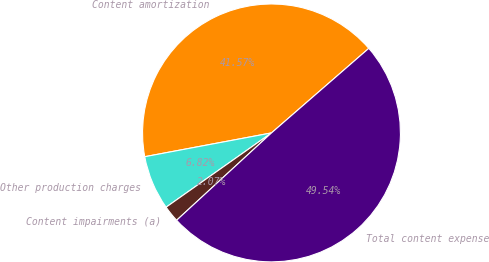<chart> <loc_0><loc_0><loc_500><loc_500><pie_chart><fcel>Content amortization<fcel>Other production charges<fcel>Content impairments (a)<fcel>Total content expense<nl><fcel>41.57%<fcel>6.82%<fcel>2.07%<fcel>49.54%<nl></chart> 